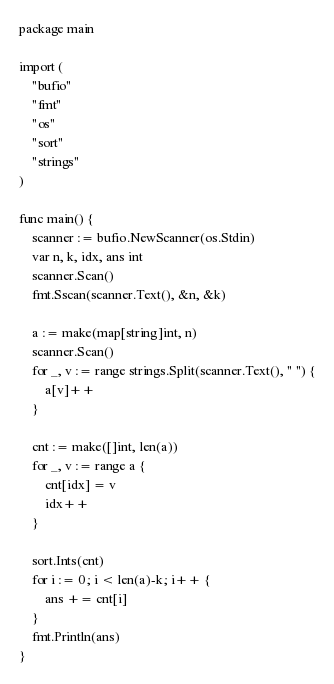<code> <loc_0><loc_0><loc_500><loc_500><_Go_>package main

import (
	"bufio"
	"fmt"
	"os"
	"sort"
	"strings"
)

func main() {
	scanner := bufio.NewScanner(os.Stdin)
	var n, k, idx, ans int
	scanner.Scan()
	fmt.Sscan(scanner.Text(), &n, &k)

	a := make(map[string]int, n)
	scanner.Scan()
	for _, v := range strings.Split(scanner.Text(), " ") {
		a[v]++
	}

	cnt := make([]int, len(a))
	for _, v := range a {
		cnt[idx] = v
		idx++
	}

	sort.Ints(cnt)
	for i := 0; i < len(a)-k; i++ {
		ans += cnt[i]
	}
	fmt.Println(ans)
}
</code> 